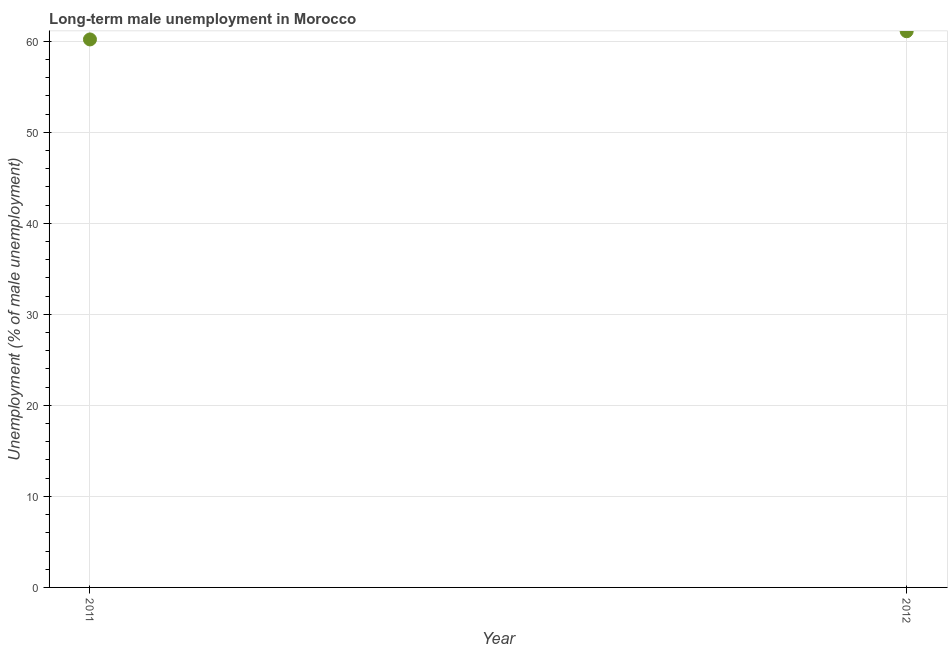What is the long-term male unemployment in 2012?
Your answer should be compact. 61.1. Across all years, what is the maximum long-term male unemployment?
Your answer should be compact. 61.1. Across all years, what is the minimum long-term male unemployment?
Keep it short and to the point. 60.2. In which year was the long-term male unemployment maximum?
Ensure brevity in your answer.  2012. In which year was the long-term male unemployment minimum?
Provide a short and direct response. 2011. What is the sum of the long-term male unemployment?
Your answer should be compact. 121.3. What is the difference between the long-term male unemployment in 2011 and 2012?
Your answer should be very brief. -0.9. What is the average long-term male unemployment per year?
Your answer should be compact. 60.65. What is the median long-term male unemployment?
Offer a very short reply. 60.65. What is the ratio of the long-term male unemployment in 2011 to that in 2012?
Give a very brief answer. 0.99. Is the long-term male unemployment in 2011 less than that in 2012?
Offer a terse response. Yes. Does the graph contain any zero values?
Provide a short and direct response. No. Does the graph contain grids?
Make the answer very short. Yes. What is the title of the graph?
Your answer should be compact. Long-term male unemployment in Morocco. What is the label or title of the X-axis?
Make the answer very short. Year. What is the label or title of the Y-axis?
Your response must be concise. Unemployment (% of male unemployment). What is the Unemployment (% of male unemployment) in 2011?
Your answer should be compact. 60.2. What is the Unemployment (% of male unemployment) in 2012?
Offer a very short reply. 61.1. What is the ratio of the Unemployment (% of male unemployment) in 2011 to that in 2012?
Your answer should be very brief. 0.98. 